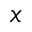<formula> <loc_0><loc_0><loc_500><loc_500>x</formula> 